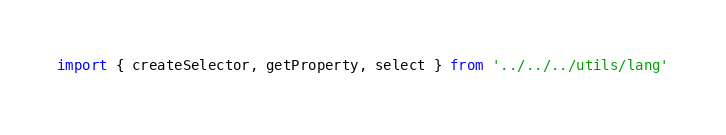Convert code to text. <code><loc_0><loc_0><loc_500><loc_500><_JavaScript_>import { createSelector, getProperty, select } from '../../../utils/lang'
</code> 